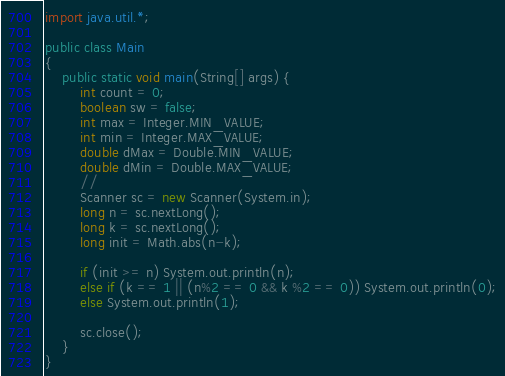Convert code to text. <code><loc_0><loc_0><loc_500><loc_500><_Java_>import java.util.*;

public class Main
{
    public static void main(String[] args) {
        int count = 0;
        boolean sw = false;
        int max = Integer.MIN_VALUE;
        int min = Integer.MAX_VALUE;
        double dMax = Double.MIN_VALUE;
        double dMin = Double.MAX_VALUE;
        //
        Scanner sc = new Scanner(System.in);
        long n = sc.nextLong();
        long k = sc.nextLong();
        long init = Math.abs(n-k);

        if (init >= n) System.out.println(n);
        else if (k == 1 || (n%2 == 0 && k %2 == 0)) System.out.println(0);
        else System.out.println(1);

        sc.close();
    }
}</code> 